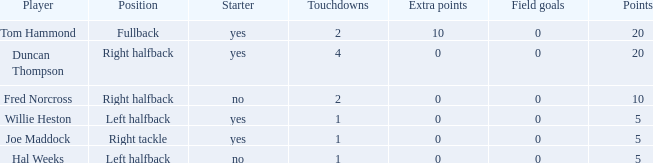Can you give me this table as a dict? {'header': ['Player', 'Position', 'Starter', 'Touchdowns', 'Extra points', 'Field goals', 'Points'], 'rows': [['Tom Hammond', 'Fullback', 'yes', '2', '10', '0', '20'], ['Duncan Thompson', 'Right halfback', 'yes', '4', '0', '0', '20'], ['Fred Norcross', 'Right halfback', 'no', '2', '0', '0', '10'], ['Willie Heston', 'Left halfback', 'yes', '1', '0', '0', '5'], ['Joe Maddock', 'Right tackle', 'yes', '1', '0', '0', '5'], ['Hal Weeks', 'Left halfback', 'no', '1', '0', '0', '5']]} What is the least number of field goals when the points were under 5? None. 